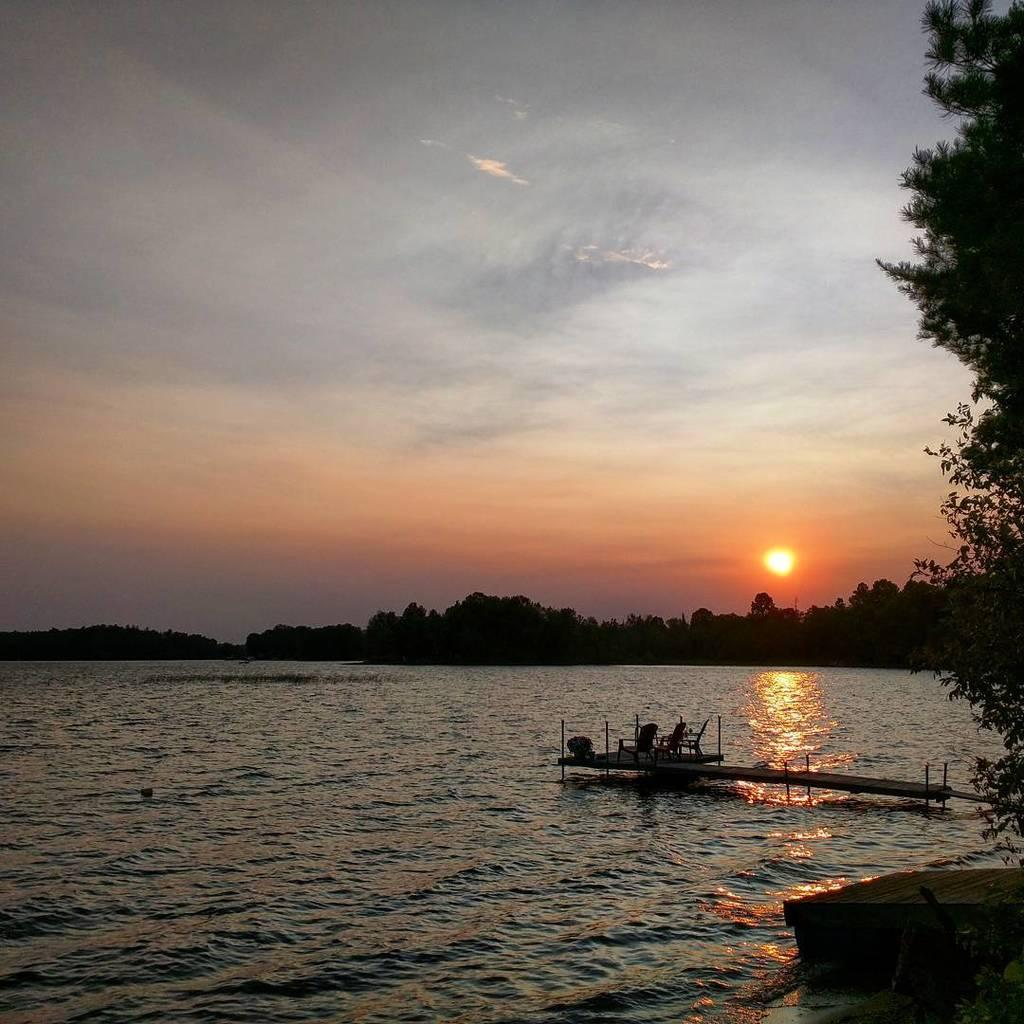What type of furniture is present in the image? There are chairs in the image. What is placed on the deck of water? There is a plant on the deck of water. What is the main feature of the landscape in the image? There is a large water body in the image. What type of vegetation can be seen in the image? There is a group of trees in the image. What celestial body is visible in the image? The sun is visible in the image. How would you describe the weather based on the image? The sky appears cloudy in the image. What type of hair can be seen growing on the trees in the image? There is no hair growing on the trees in the image; it is a group of trees with leaves and branches. Is there a dock visible in the image? There is no dock present in the image; it features a large water body, trees, and a deck of water with a plant. 